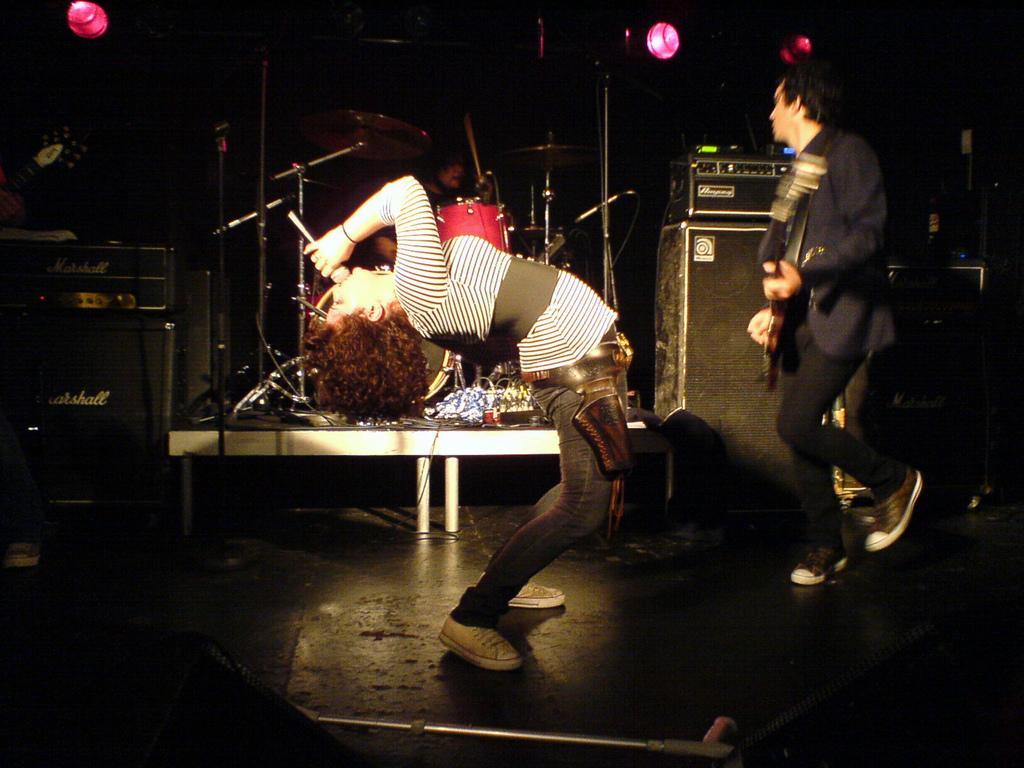In one or two sentences, can you explain what this image depicts? In the picture we can see a person bending back and singing a song in the microphone holding it and beside the person we can see a man standing and playing a musical instrument and in the background, we can see an orchestra system with some music boxes and to the ceiling we can see some lights. 